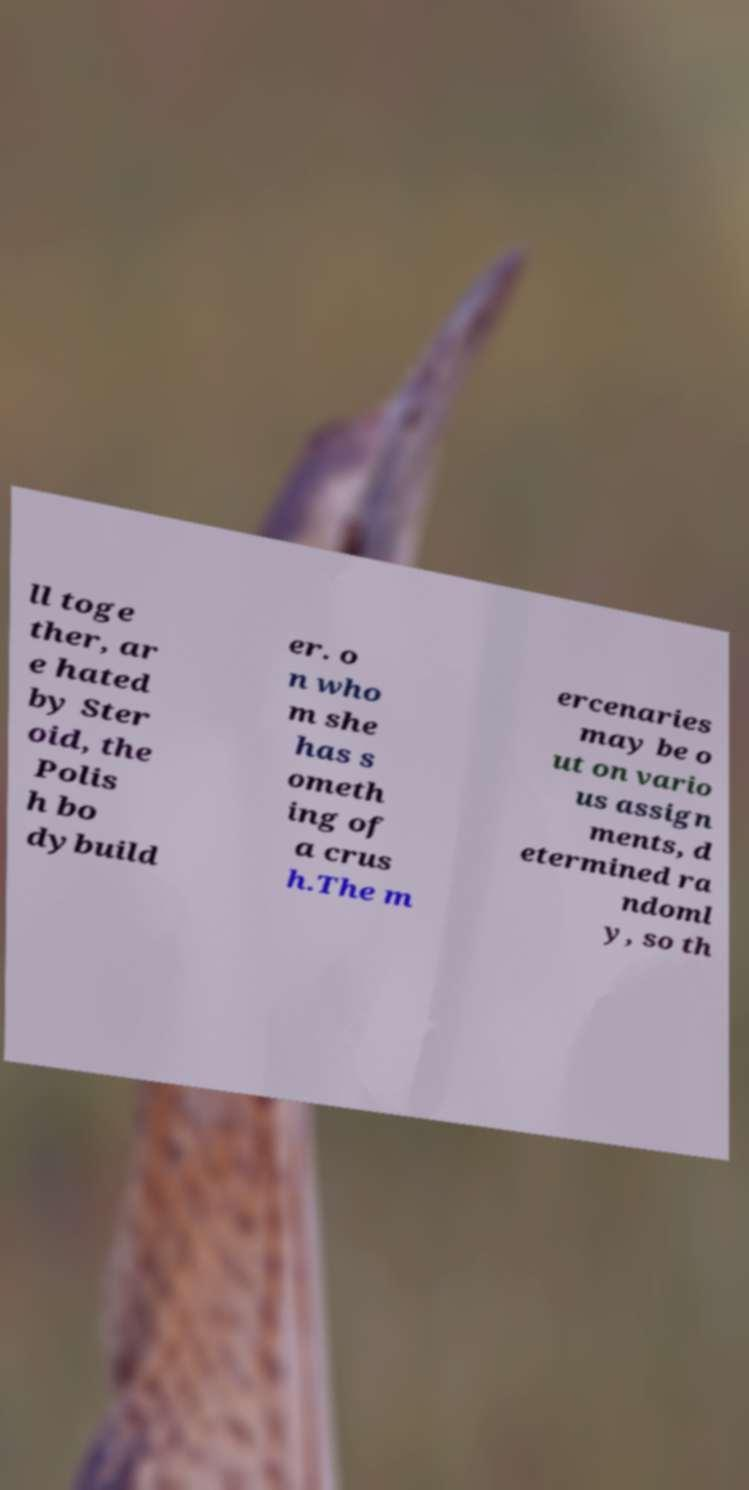Can you read and provide the text displayed in the image?This photo seems to have some interesting text. Can you extract and type it out for me? ll toge ther, ar e hated by Ster oid, the Polis h bo dybuild er. o n who m she has s ometh ing of a crus h.The m ercenaries may be o ut on vario us assign ments, d etermined ra ndoml y, so th 